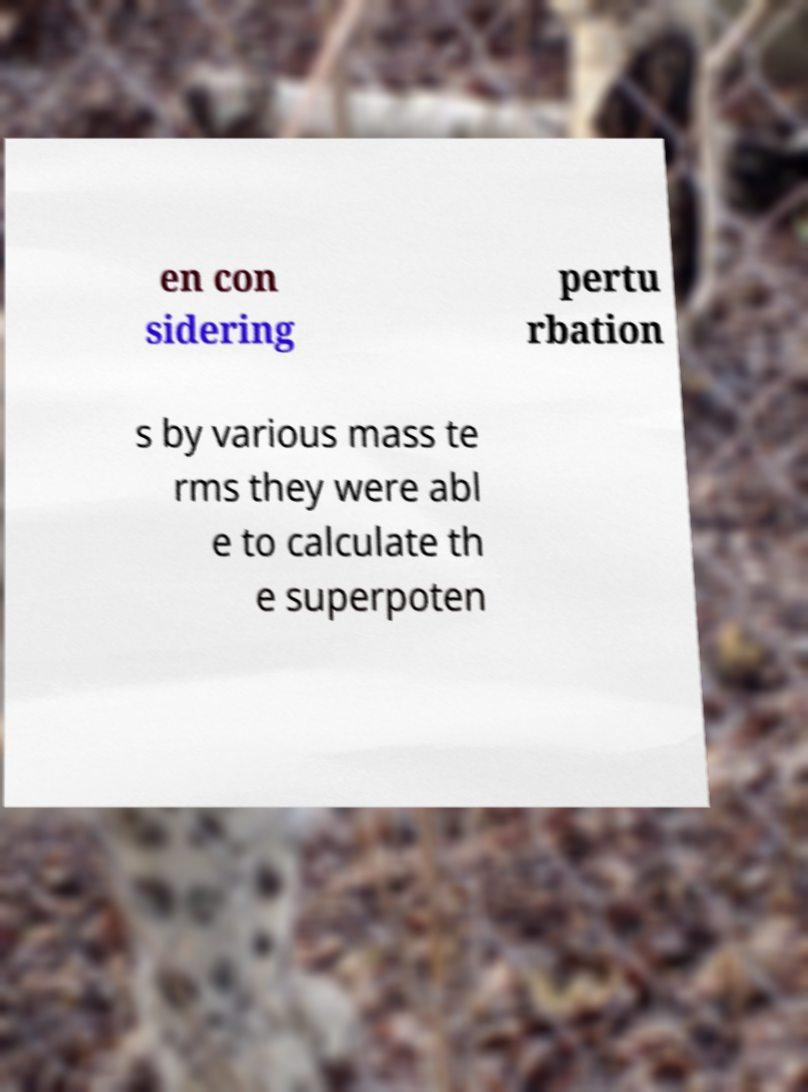There's text embedded in this image that I need extracted. Can you transcribe it verbatim? en con sidering pertu rbation s by various mass te rms they were abl e to calculate th e superpoten 